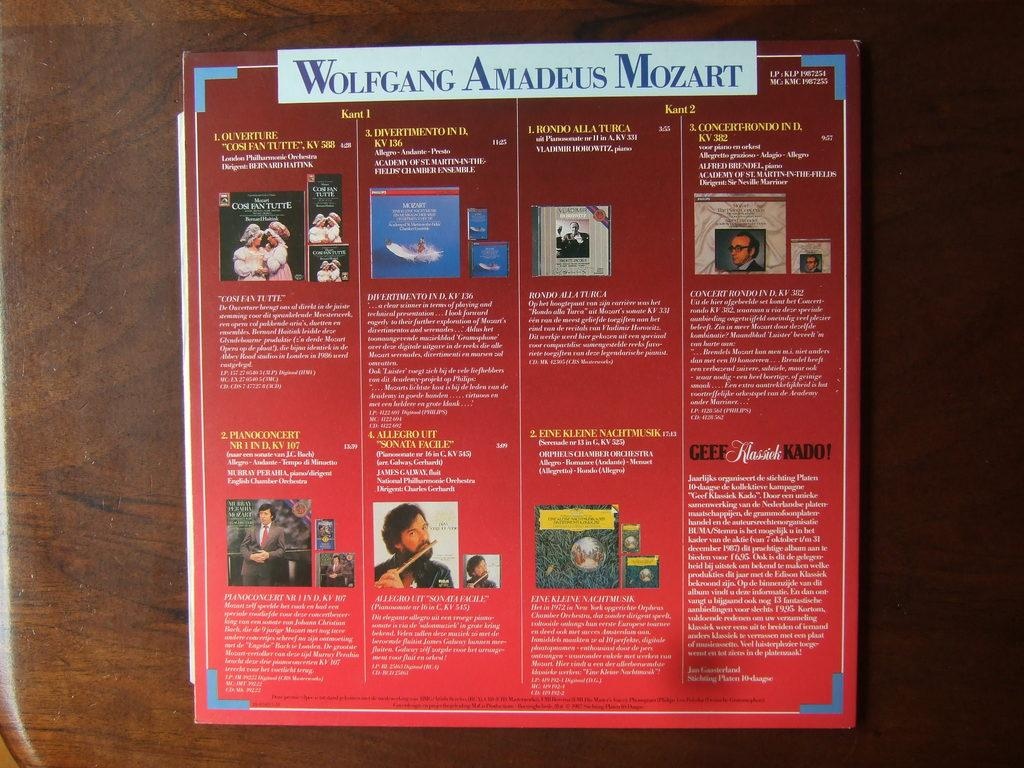<image>
Provide a brief description of the given image. a musical book item that has wolfgang as the name on top 